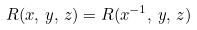<formula> <loc_0><loc_0><loc_500><loc_500>R ( x , \, y , \, z ) = R ( x ^ { - 1 } , \, y , \, z )</formula> 